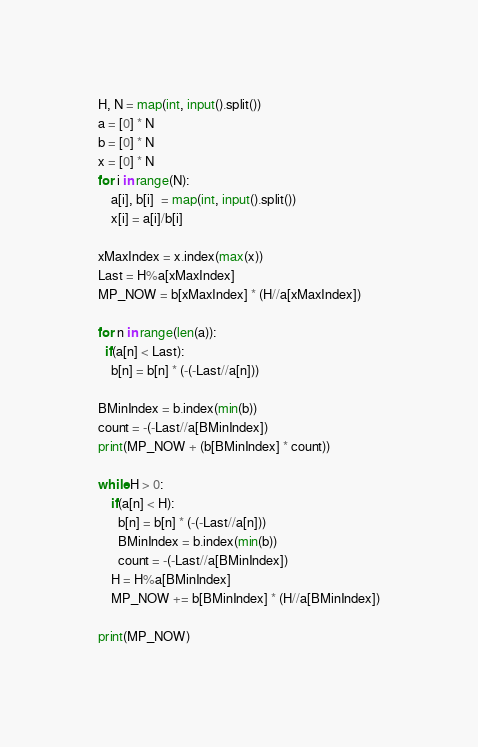Convert code to text. <code><loc_0><loc_0><loc_500><loc_500><_Python_>H, N = map(int, input().split())
a = [0] * N
b = [0] * N
x = [0] * N
for i in range(N):
    a[i], b[i]  = map(int, input().split())
    x[i] = a[i]/b[i]

xMaxIndex = x.index(max(x))
Last = H%a[xMaxIndex]
MP_NOW = b[xMaxIndex] * (H//a[xMaxIndex])

for n in range(len(a)):
  if(a[n] < Last):
    b[n] = b[n] * (-(-Last//a[n]))

BMinIndex = b.index(min(b))
count = -(-Last//a[BMinIndex])
print(MP_NOW + (b[BMinIndex] * count))

while H > 0:
    if(a[n] < H):
      b[n] = b[n] * (-(-Last//a[n]))
      BMinIndex = b.index(min(b))
      count = -(-Last//a[BMinIndex])
    H = H%a[BMinIndex]
    MP_NOW += b[BMinIndex] * (H//a[BMinIndex])

print(MP_NOW)
</code> 